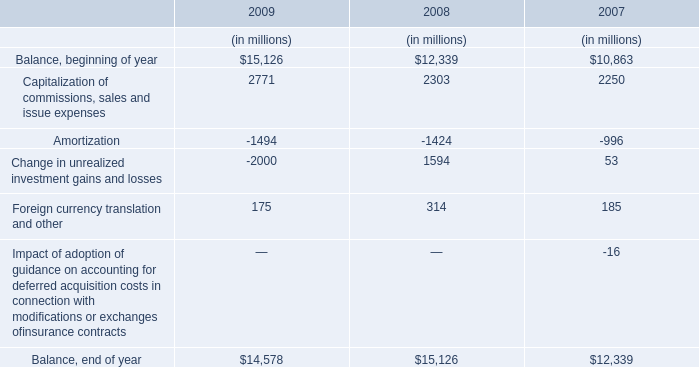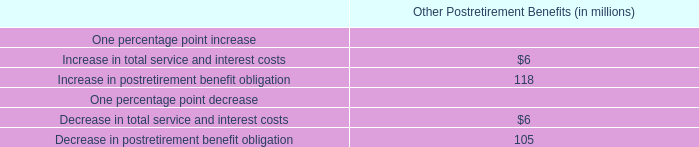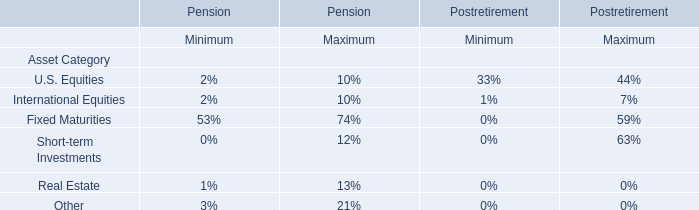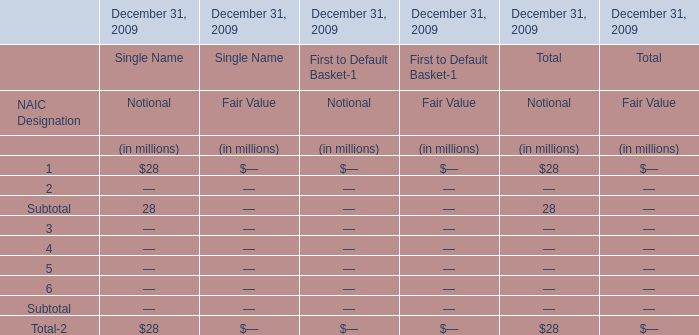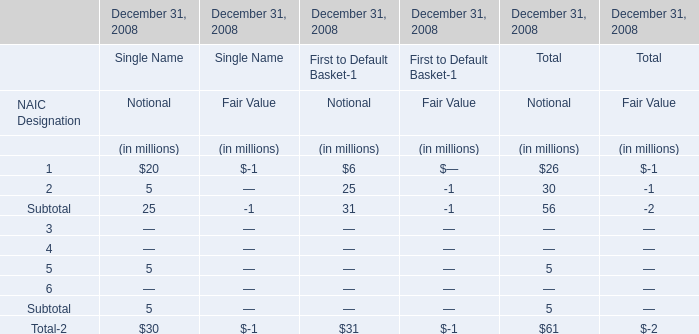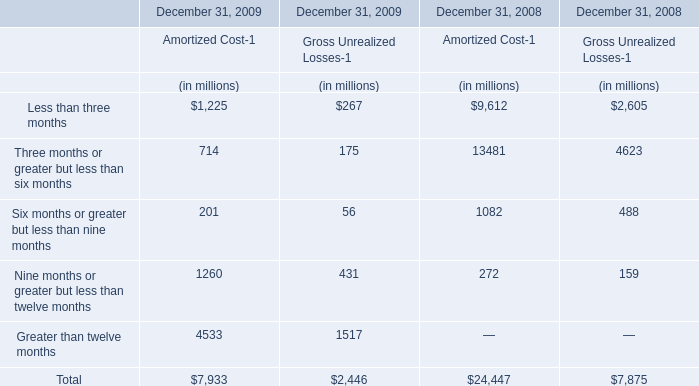In the section with largest amount of Subtotal, what's the increasing rate of Total-2? 
Computations: ((30 - -1) / 30)
Answer: 1.03333. 